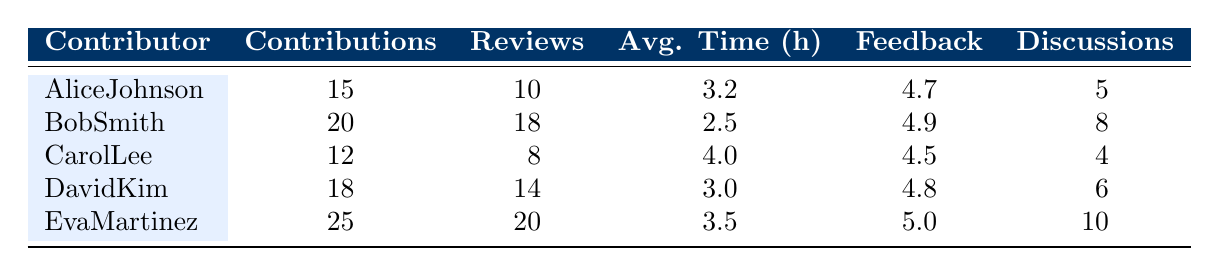What is the highest feedback score given by a contributor? The feedback score of each contributor is listed in the table. The highest score is 5.0, which belongs to Eva Martinez.
Answer: 5.0 How many code reviews did Bob Smith complete? The table shows that Bob Smith completed 18 code reviews.
Answer: 18 Which contributor has the lowest average review time? The average review time for each contributor is shown, and Bob Smith has the lowest average review time of 2.5 hours.
Answer: 2.5 What is the total number of contributions made by all contributors? To find the total contributions, we sum the contributions from each contributor: 15 (Alice) + 20 (Bob) + 12 (Carol) + 18 (David) + 25 (Eva) = 90.
Answer: 90 Is it true that Carol Lee participated in more discussions than David Kim? Carol Lee participated in 4 discussions while David Kim participated in 6 discussions, so it is not true.
Answer: No What is the average number of code reviews completed by the contributors? To find the average, we sum the completed reviews: 10 + 18 + 8 + 14 + 20 = 70, then divide by the number of contributors (5): 70 / 5 = 14.
Answer: 14 Who has the most contributions and what is that number? Looking at the contributions column, Eva Martinez has the most contributions with a count of 25.
Answer: Eva Martinez, 25 What is the difference in average review time between the fastest and slowest reviewers? The fastest reviewer, Bob Smith, has an average review time of 2.5 hours, while Carol Lee has the slowest at 4.0 hours. The difference is 4.0 - 2.5 = 1.5 hours.
Answer: 1.5 Did Eva Martinez complete at least 15 code reviews? According to the table, Eva Martinez completed 20 code reviews, which is greater than 15, so the statement is true.
Answer: Yes 